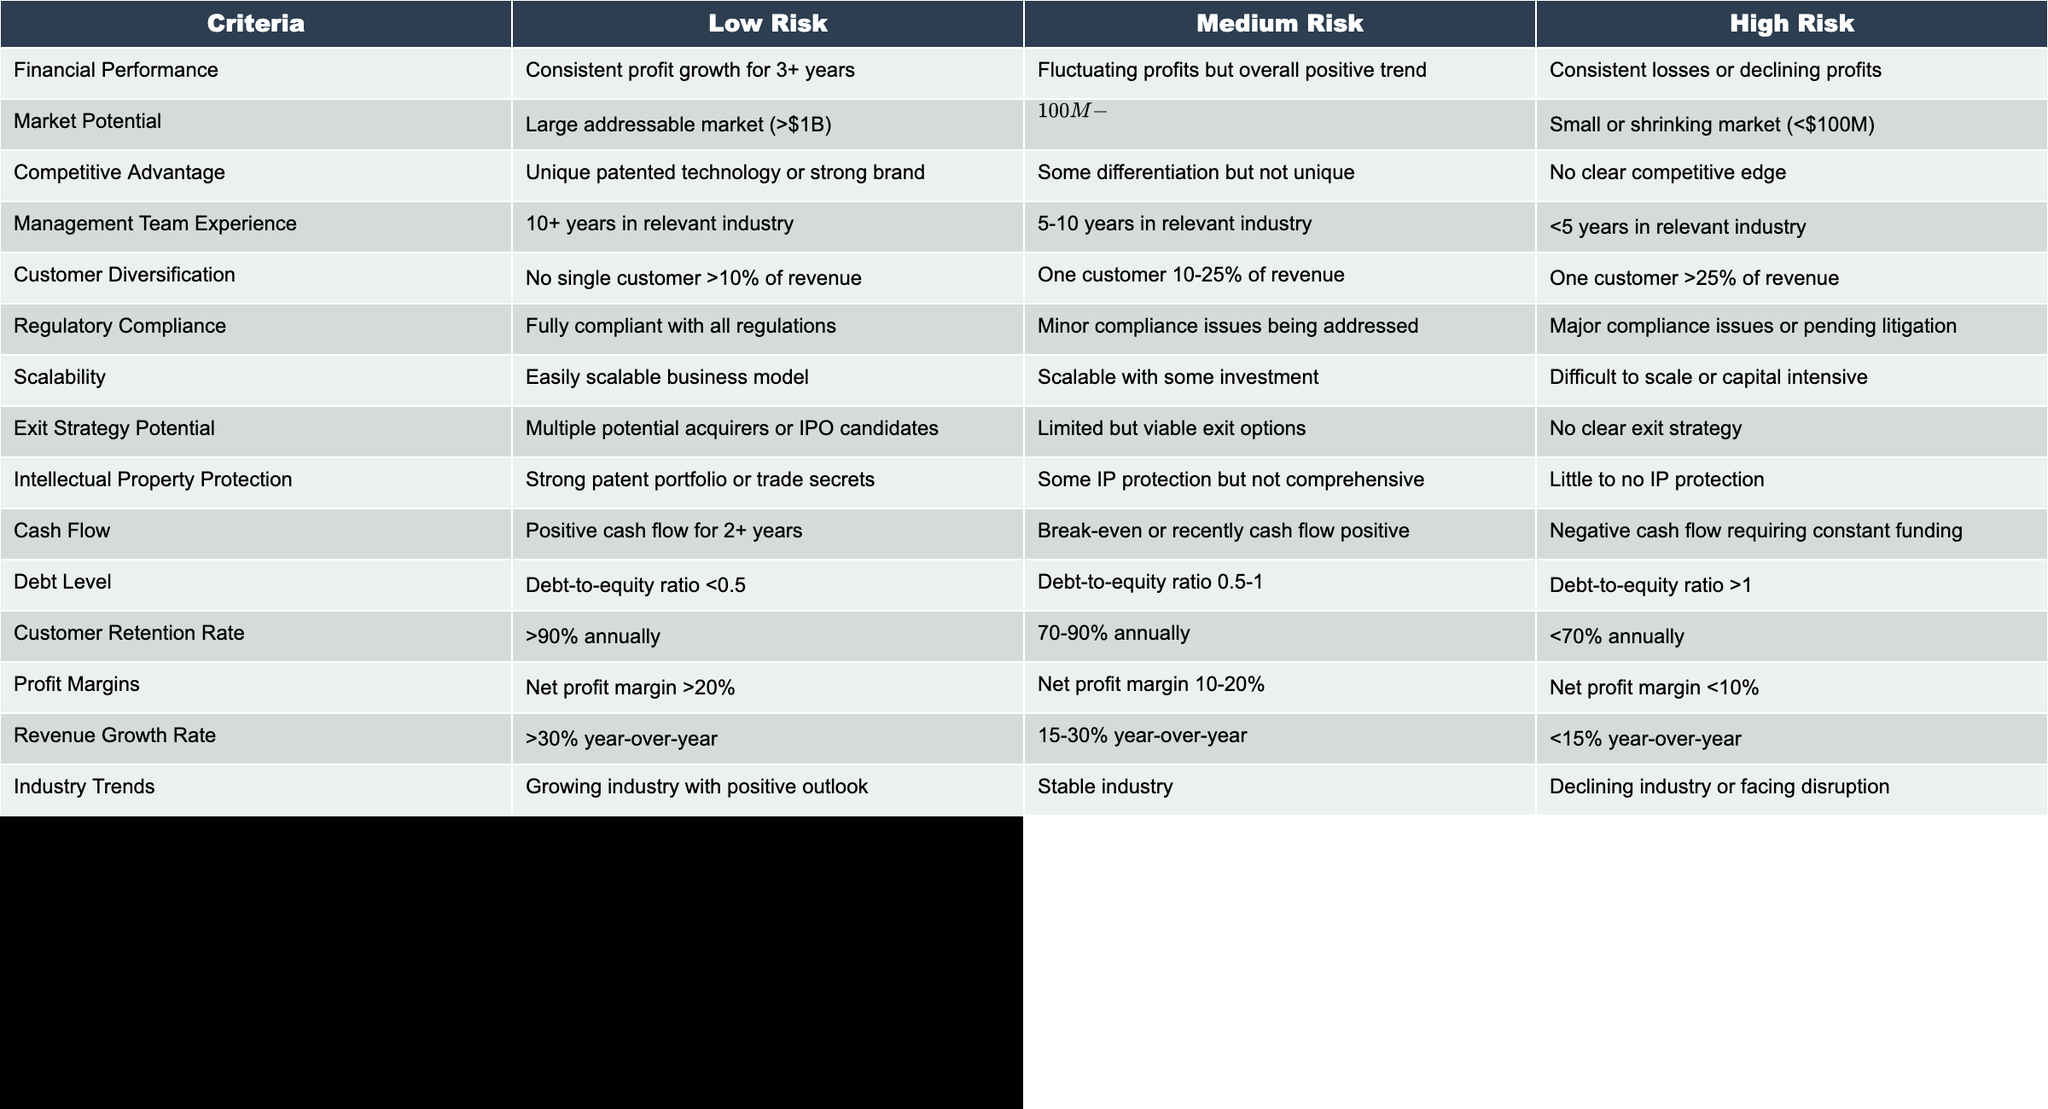What is the maximum duration of consistent profit growth indicated? The table states that consistent profit growth is classified as a low-risk criterion, specifically requiring 3 or more years of consistent profit growth.
Answer: 3+ years What percentage of revenue from a single customer is deemed as high risk? A single customer contributing over 25% of total revenue is categorized as high risk in the table.
Answer: >25% Is a moderate market size considered low risk or medium risk? The table categorizes a moderate market size, defined as an addressable market between $100 million and $1 billion, as medium risk.
Answer: Medium risk How many criteria are associated with high risk in the management team experience field? The table indicates that management team experience under five years is categorized as high risk. Therefore, there is one criterion for high risk in this section.
Answer: 1 criterion If a business has a debt-to-equity ratio of 0.8, what is the risk level associated with its debt level? According to the table, a debt-to-equity ratio between 0.5 and 1 is classified as medium risk. A ratio of 0.8 falls within this range.
Answer: Medium risk Considering customer retention rates, how does >90% retention compare to <70% retention in terms of risk? The table shows that a retention rate of over 90% is labeled as low risk, while a retention rate below 70% is labeled as high risk. This indicates a clear difference of two risk levels.
Answer: Low risk vs. high risk What is the implication of a business being in a declining industry regarding its risk profile? The table classifies businesses in a declining industry or facing disruption as high risk, as opposed to those in growing or stable industries, which are lower risk.
Answer: High risk If a company's cash flow is negative but improving toward breaking even, what risk level might apply? Based on the table’s information, a company currently experiencing negative cash flow would likely categorize as high risk, despite improvement efforts. Thus, it is high risk until it achieves break-even.
Answer: High risk 